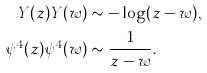Convert formula to latex. <formula><loc_0><loc_0><loc_500><loc_500>Y ( z ) Y ( w ) & \sim - \log ( z - w ) , \\ \psi ^ { 4 } ( z ) \psi ^ { 4 } ( w ) & \sim \frac { 1 } { z - w } .</formula> 